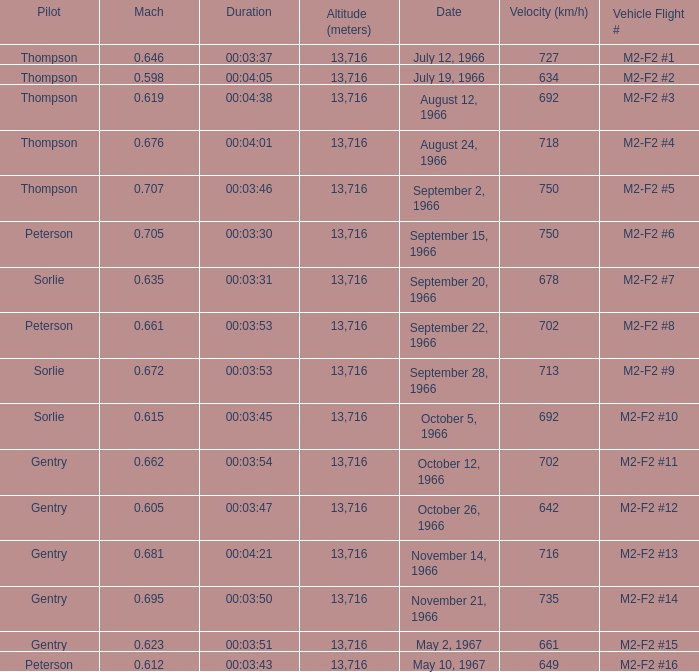What Date has a Mach of 0.662? October 12, 1966. 